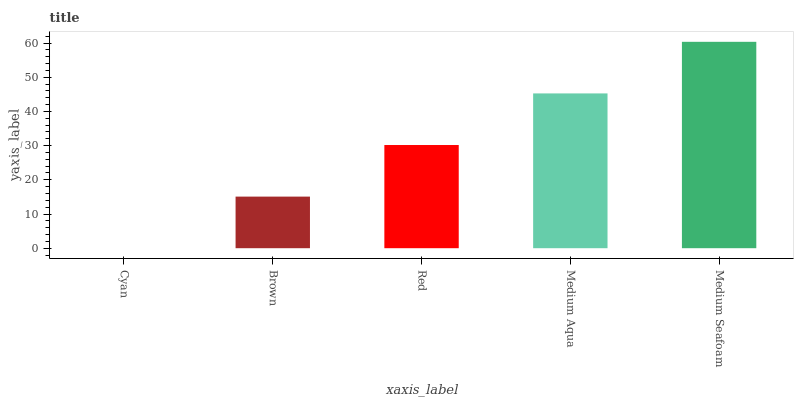Is Cyan the minimum?
Answer yes or no. Yes. Is Medium Seafoam the maximum?
Answer yes or no. Yes. Is Brown the minimum?
Answer yes or no. No. Is Brown the maximum?
Answer yes or no. No. Is Brown greater than Cyan?
Answer yes or no. Yes. Is Cyan less than Brown?
Answer yes or no. Yes. Is Cyan greater than Brown?
Answer yes or no. No. Is Brown less than Cyan?
Answer yes or no. No. Is Red the high median?
Answer yes or no. Yes. Is Red the low median?
Answer yes or no. Yes. Is Medium Seafoam the high median?
Answer yes or no. No. Is Cyan the low median?
Answer yes or no. No. 